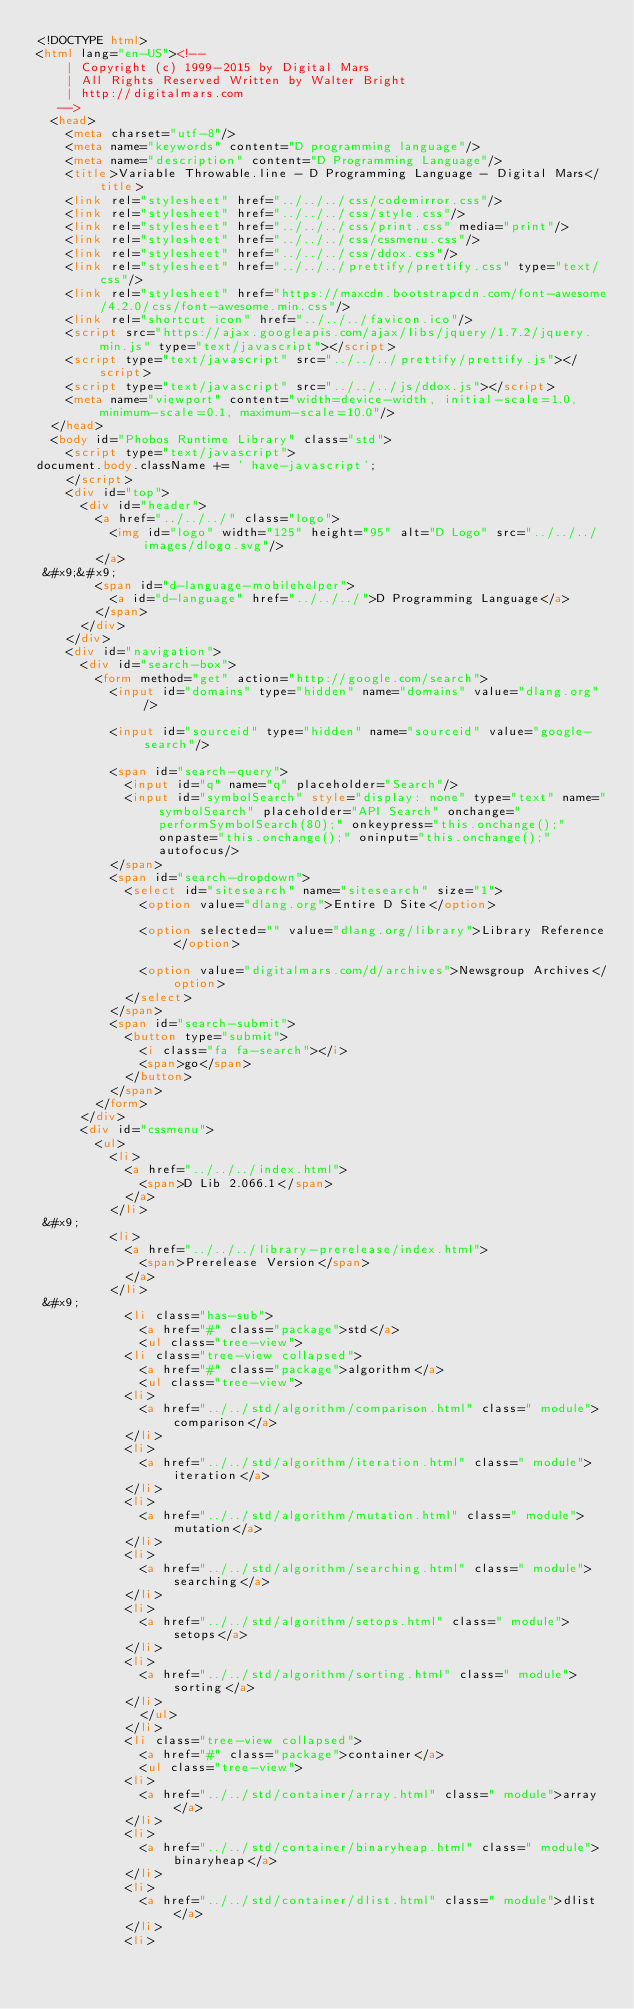<code> <loc_0><loc_0><loc_500><loc_500><_HTML_><!DOCTYPE html>
<html lang="en-US"><!-- 
    | Copyright (c) 1999-2015 by Digital Mars
    | All Rights Reserved Written by Walter Bright
    | http://digitalmars.com
	 -->
	<head>
		<meta charset="utf-8"/>
		<meta name="keywords" content="D programming language"/>
		<meta name="description" content="D Programming Language"/>
		<title>Variable Throwable.line - D Programming Language - Digital Mars</title>
		<link rel="stylesheet" href="../../../css/codemirror.css"/>
		<link rel="stylesheet" href="../../../css/style.css"/>
		<link rel="stylesheet" href="../../../css/print.css" media="print"/>
		<link rel="stylesheet" href="../../../css/cssmenu.css"/>
		<link rel="stylesheet" href="../../../css/ddox.css"/>
		<link rel="stylesheet" href="../../../prettify/prettify.css" type="text/css"/>
		<link rel="stylesheet" href="https://maxcdn.bootstrapcdn.com/font-awesome/4.2.0/css/font-awesome.min.css"/>
		<link rel="shortcut icon" href="../../../favicon.ico"/>
		<script src="https://ajax.googleapis.com/ajax/libs/jquery/1.7.2/jquery.min.js" type="text/javascript"></script>
		<script type="text/javascript" src="../../../prettify/prettify.js"></script>
		<script type="text/javascript" src="../../../js/ddox.js"></script>
		<meta name="viewport" content="width=device-width, initial-scale=1.0, minimum-scale=0.1, maximum-scale=10.0"/>
	</head>
	<body id="Phobos Runtime Library" class="std">
		<script type="text/javascript">
document.body.className += ' have-javascript';
		</script>
		<div id="top">
			<div id="header">
				<a href="../../../" class="logo">
					<img id="logo" width="125" height="95" alt="D Logo" src="../../../images/dlogo.svg"/>
				</a>
 &#x9;&#x9;
				<span id="d-language-mobilehelper">
					<a id="d-language" href="../../../">D Programming Language</a>
				</span>
			</div>
		</div>
		<div id="navigation">
			<div id="search-box">
				<form method="get" action="http://google.com/search">
					<input id="domains" type="hidden" name="domains" value="dlang.org"/>
             
					<input id="sourceid" type="hidden" name="sourceid" value="google-search"/>
             
					<span id="search-query">
						<input id="q" name="q" placeholder="Search"/>
						<input id="symbolSearch" style="display: none" type="text" name="symbolSearch" placeholder="API Search" onchange="performSymbolSearch(80);" onkeypress="this.onchange();" onpaste="this.onchange();" oninput="this.onchange();" autofocus/>
					</span>
					<span id="search-dropdown">
						<select id="sitesearch" name="sitesearch" size="1">
							<option value="dlang.org">Entire D Site</option>
                     
							<option selected="" value="dlang.org/library">Library Reference</option>
                     
							<option value="digitalmars.com/d/archives">Newsgroup Archives</option>
						</select>
					</span>
					<span id="search-submit">
						<button type="submit">
							<i class="fa fa-search"></i>
							<span>go</span>
						</button>
					</span>
				</form>
			</div>
			<div id="cssmenu">
				<ul>
					<li>
						<a href="../../../index.html">
							<span>D Lib 2.066.1</span>
						</a>
					</li>
 &#x9;
					<li>
						<a href="../../../library-prerelease/index.html">
							<span>Prerelease Version</span>
						</a>
					</li>
 &#x9;
						<li class="has-sub">
							<a href="#" class="package">std</a>
							<ul class="tree-view">
						<li class="tree-view collapsed">
							<a href="#" class="package">algorithm</a>
							<ul class="tree-view">
						<li>
							<a href="../../std/algorithm/comparison.html" class=" module">comparison</a>
						</li>
						<li>
							<a href="../../std/algorithm/iteration.html" class=" module">iteration</a>
						</li>
						<li>
							<a href="../../std/algorithm/mutation.html" class=" module">mutation</a>
						</li>
						<li>
							<a href="../../std/algorithm/searching.html" class=" module">searching</a>
						</li>
						<li>
							<a href="../../std/algorithm/setops.html" class=" module">setops</a>
						</li>
						<li>
							<a href="../../std/algorithm/sorting.html" class=" module">sorting</a>
						</li>
							</ul>
						</li>
						<li class="tree-view collapsed">
							<a href="#" class="package">container</a>
							<ul class="tree-view">
						<li>
							<a href="../../std/container/array.html" class=" module">array</a>
						</li>
						<li>
							<a href="../../std/container/binaryheap.html" class=" module">binaryheap</a>
						</li>
						<li>
							<a href="../../std/container/dlist.html" class=" module">dlist</a>
						</li>
						<li></code> 